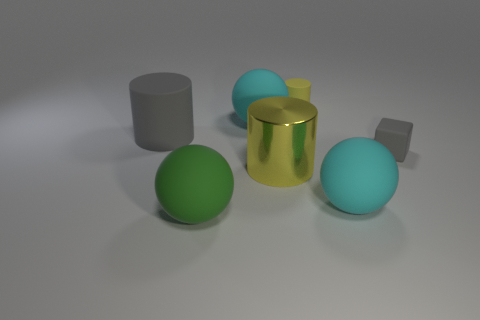What number of cylinders are the same color as the small matte block?
Ensure brevity in your answer.  1. How many spheres are either big green things or yellow objects?
Your answer should be compact. 1. There is another cylinder that is the same size as the gray cylinder; what is its color?
Give a very brief answer. Yellow. There is a gray matte thing on the right side of the big rubber ball that is to the right of the small yellow matte cylinder; are there any big cyan rubber objects behind it?
Give a very brief answer. Yes. What is the size of the yellow rubber object?
Provide a short and direct response. Small. What number of things are large yellow cylinders or cylinders?
Your answer should be compact. 3. There is another small object that is the same material as the tiny gray thing; what is its color?
Your answer should be very brief. Yellow. There is a big thing that is on the left side of the green matte thing; does it have the same shape as the yellow metal thing?
Make the answer very short. Yes. What number of things are objects on the right side of the green rubber object or large matte spheres right of the green sphere?
Keep it short and to the point. 5. What is the color of the other matte thing that is the same shape as the small yellow rubber thing?
Offer a terse response. Gray. 